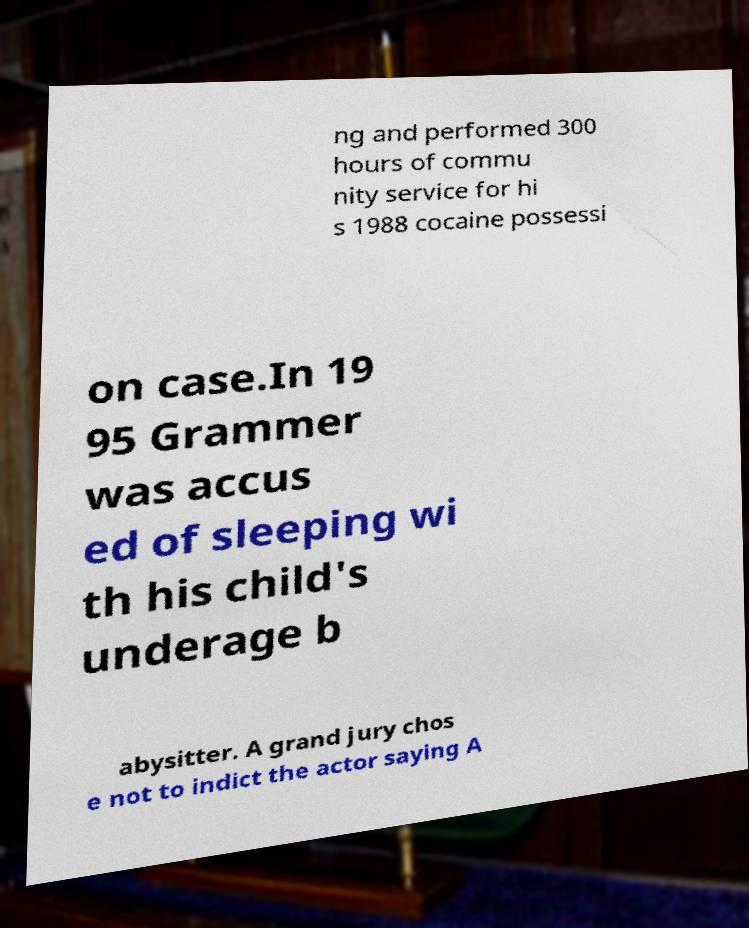For documentation purposes, I need the text within this image transcribed. Could you provide that? ng and performed 300 hours of commu nity service for hi s 1988 cocaine possessi on case.In 19 95 Grammer was accus ed of sleeping wi th his child's underage b abysitter. A grand jury chos e not to indict the actor saying A 